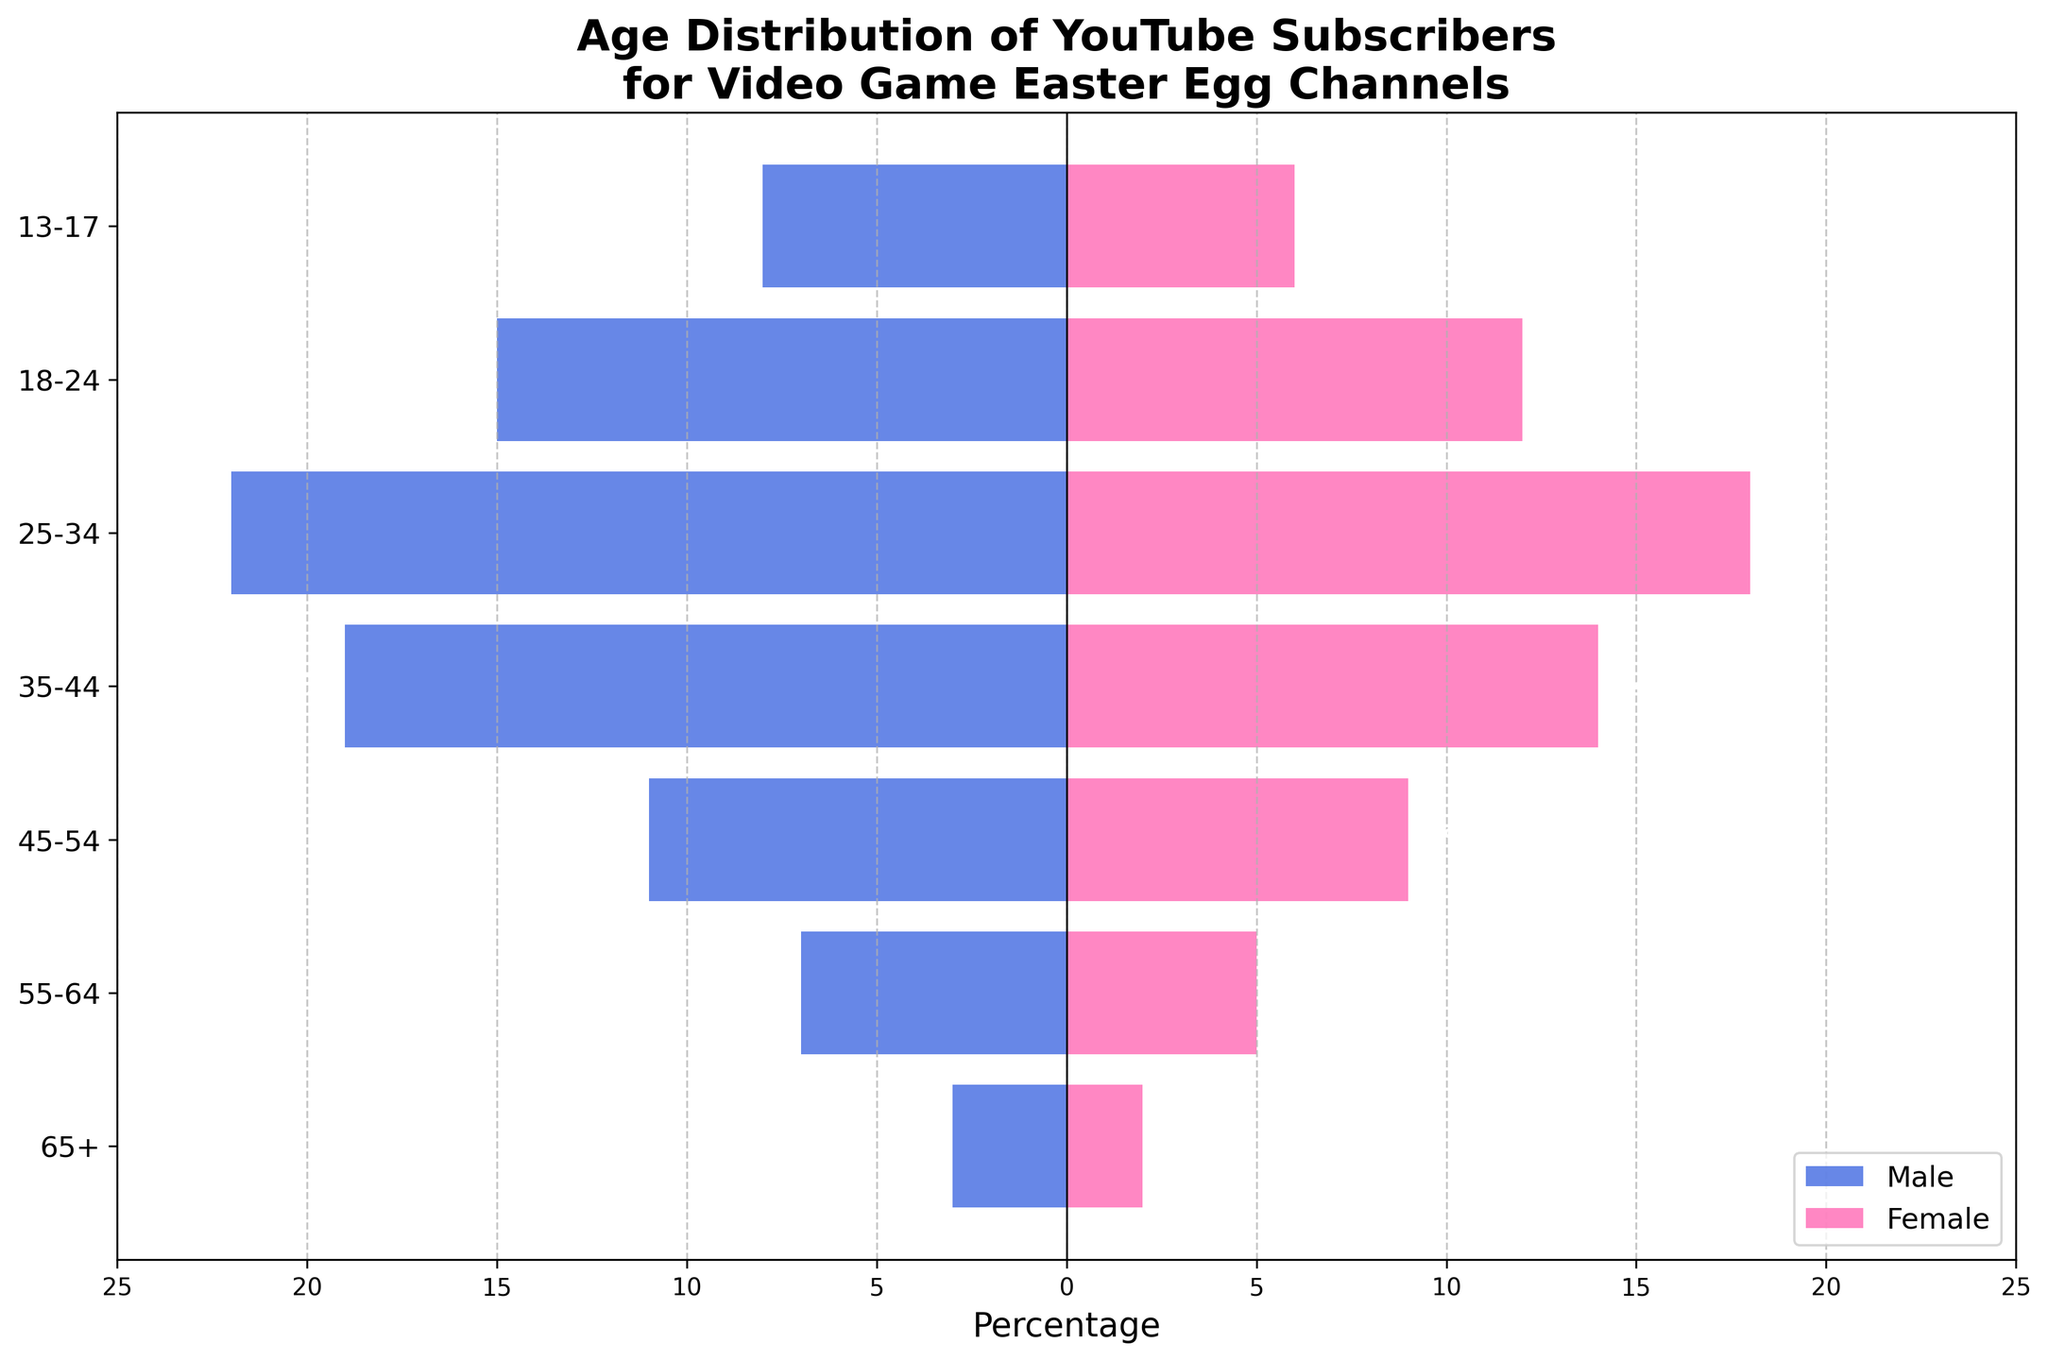What is the title of the figure? The title appears at the top of the figure, clearly stating what the data represents.
Answer: Age Distribution of YouTube Subscribers for Video Game Easter Egg Channels What age group has the highest percentage of male subscribers? To find this, look at the length of the horizontal bars on the left side of the figure. The longest bar represents the age group with the highest percentage.
Answer: 25-34 In which age group is the percentage of female subscribers the lowest? Check the horizontal bars on the right side of the figure and identify the shortest bar, which indicates the lowest percentage of female subscribers.
Answer: 65+ How does the number of male subscribers in the 35-44 age group compare to those in the 18-24 age group? Look at the lengths of the bars for males in the 35-44 and 18-24 age groups. The bar for 35-44 is shorter than that for 18-24.
Answer: Lower What is the difference in the percentage of subscribers between males and females in the 45-54 age group? Calculate the difference by subtracting the female percentage from the male percentage for the 45-54 age group: 11 - 9 = 2.
Answer: 2% What proportion of the 25-34 age group are female subscribers? Refer to the bar for females in the 25-34 age group. The total subscribers in this age group are the sum of males and females (22 + 18 = 40). The proportion of females is 18 out of 40.
Answer: 45% Which age group has the closest male to female subscriber ratio? Compare the lengths of male and female bars across age groups to find the pair that are most similar in length.
Answer: 55-64 How does the age distribution of male subscribers differ from that of female subscribers? Male subscribers have longer bars in almost all age groups, indicating a higher percentage, especially in the middle age ranges. Females have lower percentages consistently across all age groups.
Answer: Males have higher percentages What is the total percentage of subscribers aged 55+ for each gender? Add the percentages for the 55-64 and 65+ age groups for each gender. For males: 7+3=10; for females: 5+2=7.
Answer: Males: 10%, Females: 7% By how much do male subscribers in the 25-34 age group outnumber those in the 13-17 age group? Subtract the percentage of males in the 13-17 age group from that in the 25-34 age group: 22 - 8 = 14.
Answer: 14% 